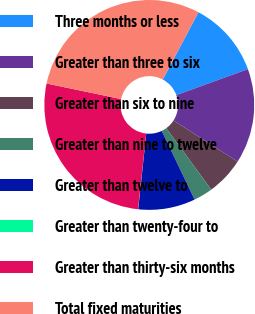<chart> <loc_0><loc_0><loc_500><loc_500><pie_chart><fcel>Three months or less<fcel>Greater than three to six<fcel>Greater than six to nine<fcel>Greater than nine to twelve<fcel>Greater than twelve to<fcel>Greater than twenty-four to<fcel>Greater than thirty-six months<fcel>Total fixed maturities<nl><fcel>11.7%<fcel>14.62%<fcel>5.87%<fcel>2.95%<fcel>8.79%<fcel>0.03%<fcel>26.56%<fcel>29.48%<nl></chart> 